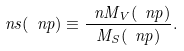Convert formula to latex. <formula><loc_0><loc_0><loc_500><loc_500>\ n s ( \ n p ) \equiv \frac { \ n M _ { V } ( \ n p ) } { M _ { S } ( \ n p ) } .</formula> 